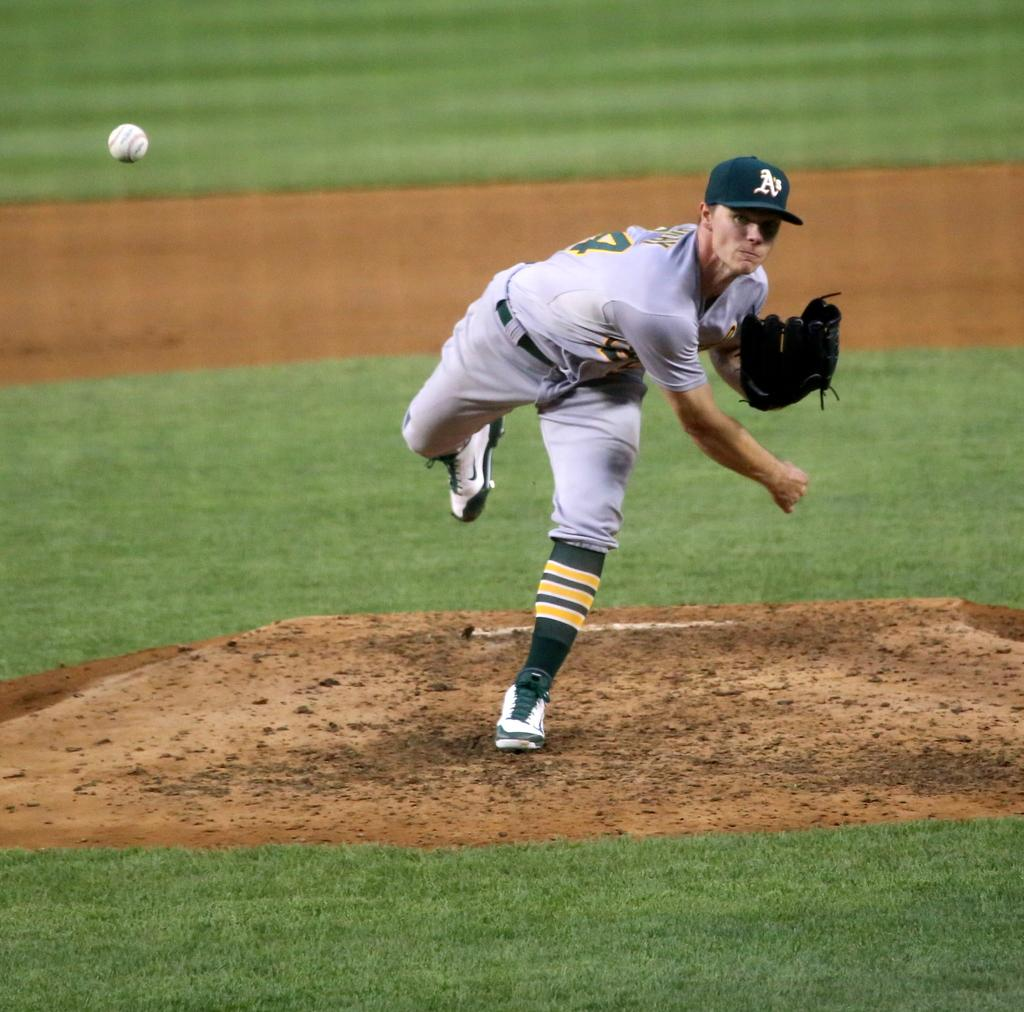<image>
Provide a brief description of the given image. The pitcher has the letter A on his green hat 